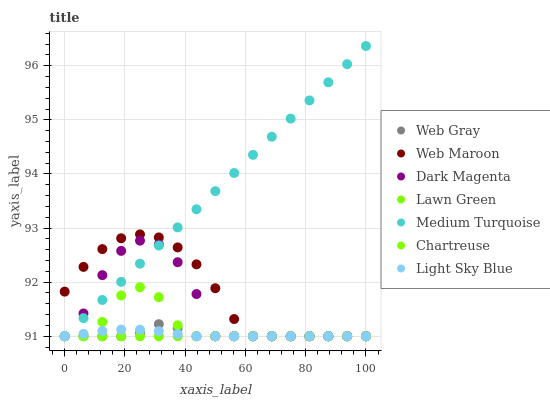Does Lawn Green have the minimum area under the curve?
Answer yes or no. Yes. Does Medium Turquoise have the maximum area under the curve?
Answer yes or no. Yes. Does Web Gray have the minimum area under the curve?
Answer yes or no. No. Does Web Gray have the maximum area under the curve?
Answer yes or no. No. Is Medium Turquoise the smoothest?
Answer yes or no. Yes. Is Dark Magenta the roughest?
Answer yes or no. Yes. Is Web Gray the smoothest?
Answer yes or no. No. Is Web Gray the roughest?
Answer yes or no. No. Does Lawn Green have the lowest value?
Answer yes or no. Yes. Does Medium Turquoise have the highest value?
Answer yes or no. Yes. Does Web Gray have the highest value?
Answer yes or no. No. Does Lawn Green intersect Medium Turquoise?
Answer yes or no. Yes. Is Lawn Green less than Medium Turquoise?
Answer yes or no. No. Is Lawn Green greater than Medium Turquoise?
Answer yes or no. No. 